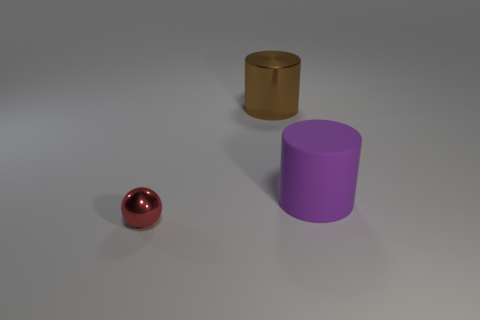Add 1 gray shiny blocks. How many objects exist? 4 Subtract all balls. How many objects are left? 2 Add 3 brown metal cylinders. How many brown metal cylinders are left? 4 Add 1 yellow matte spheres. How many yellow matte spheres exist? 1 Subtract 0 cyan cylinders. How many objects are left? 3 Subtract all small metallic spheres. Subtract all large purple matte cylinders. How many objects are left? 1 